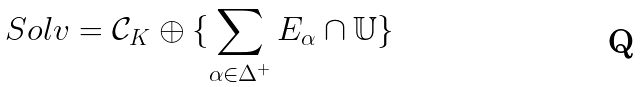Convert formula to latex. <formula><loc_0><loc_0><loc_500><loc_500>S o l v = \mathcal { C } _ { K } \oplus \{ \sum _ { \alpha \in \Delta ^ { + } } E _ { \alpha } \cap \mathbb { U } \}</formula> 